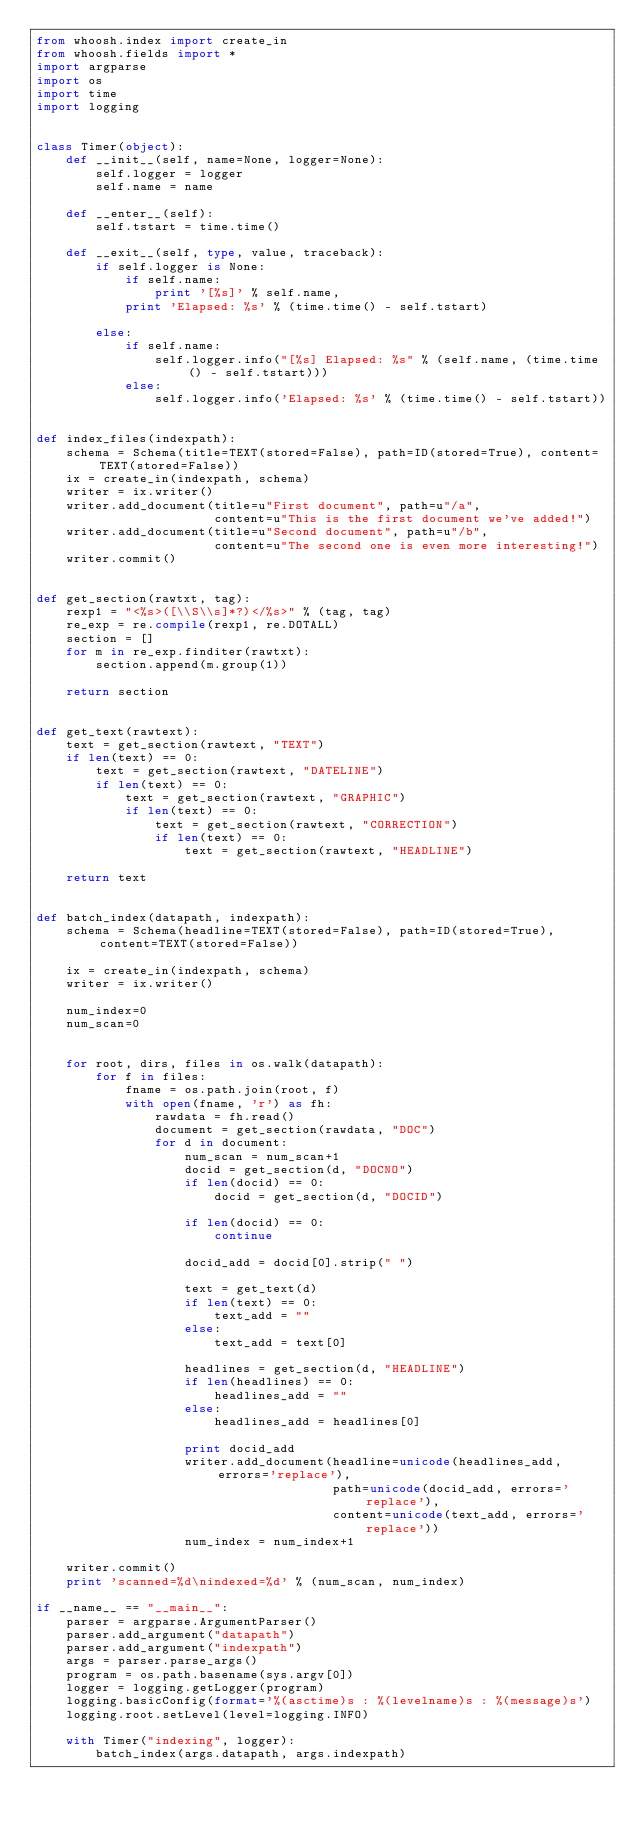Convert code to text. <code><loc_0><loc_0><loc_500><loc_500><_Python_>from whoosh.index import create_in
from whoosh.fields import *
import argparse
import os
import time
import logging


class Timer(object):
    def __init__(self, name=None, logger=None):
        self.logger = logger
        self.name = name

    def __enter__(self):
        self.tstart = time.time()

    def __exit__(self, type, value, traceback):
        if self.logger is None:
            if self.name:
                print '[%s]' % self.name,
            print 'Elapsed: %s' % (time.time() - self.tstart)

        else:
            if self.name:
                self.logger.info("[%s] Elapsed: %s" % (self.name, (time.time() - self.tstart)))
            else:
                self.logger.info('Elapsed: %s' % (time.time() - self.tstart))


def index_files(indexpath):
    schema = Schema(title=TEXT(stored=False), path=ID(stored=True), content=TEXT(stored=False))
    ix = create_in(indexpath, schema)
    writer = ix.writer()
    writer.add_document(title=u"First document", path=u"/a",
                        content=u"This is the first document we've added!")
    writer.add_document(title=u"Second document", path=u"/b",
                        content=u"The second one is even more interesting!")
    writer.commit()


def get_section(rawtxt, tag):
    rexp1 = "<%s>([\\S\\s]*?)</%s>" % (tag, tag)
    re_exp = re.compile(rexp1, re.DOTALL)
    section = []
    for m in re_exp.finditer(rawtxt):
        section.append(m.group(1))

    return section


def get_text(rawtext):
    text = get_section(rawtext, "TEXT")
    if len(text) == 0:
        text = get_section(rawtext, "DATELINE")
        if len(text) == 0:
            text = get_section(rawtext, "GRAPHIC")
            if len(text) == 0:
                text = get_section(rawtext, "CORRECTION")
                if len(text) == 0:
                    text = get_section(rawtext, "HEADLINE")

    return text


def batch_index(datapath, indexpath):
    schema = Schema(headline=TEXT(stored=False), path=ID(stored=True), content=TEXT(stored=False))

    ix = create_in(indexpath, schema)
    writer = ix.writer()

    num_index=0
    num_scan=0


    for root, dirs, files in os.walk(datapath):
        for f in files:
            fname = os.path.join(root, f)
            with open(fname, 'r') as fh:
                rawdata = fh.read()
                document = get_section(rawdata, "DOC")
                for d in document:
                    num_scan = num_scan+1
                    docid = get_section(d, "DOCNO")
                    if len(docid) == 0:
                        docid = get_section(d, "DOCID")

                    if len(docid) == 0:
                        continue

                    docid_add = docid[0].strip(" ")

                    text = get_text(d)
                    if len(text) == 0:
                        text_add = ""
                    else:
                        text_add = text[0]

                    headlines = get_section(d, "HEADLINE")
                    if len(headlines) == 0:
                        headlines_add = ""
                    else:
                        headlines_add = headlines[0]

                    print docid_add
                    writer.add_document(headline=unicode(headlines_add, errors='replace'),
                                        path=unicode(docid_add, errors='replace'),
                                        content=unicode(text_add, errors='replace'))
                    num_index = num_index+1

    writer.commit()
    print 'scanned=%d\nindexed=%d' % (num_scan, num_index)

if __name__ == "__main__":
    parser = argparse.ArgumentParser()
    parser.add_argument("datapath")
    parser.add_argument("indexpath")
    args = parser.parse_args()
    program = os.path.basename(sys.argv[0])
    logger = logging.getLogger(program)
    logging.basicConfig(format='%(asctime)s : %(levelname)s : %(message)s')
    logging.root.setLevel(level=logging.INFO)

    with Timer("indexing", logger):
        batch_index(args.datapath, args.indexpath)



</code> 